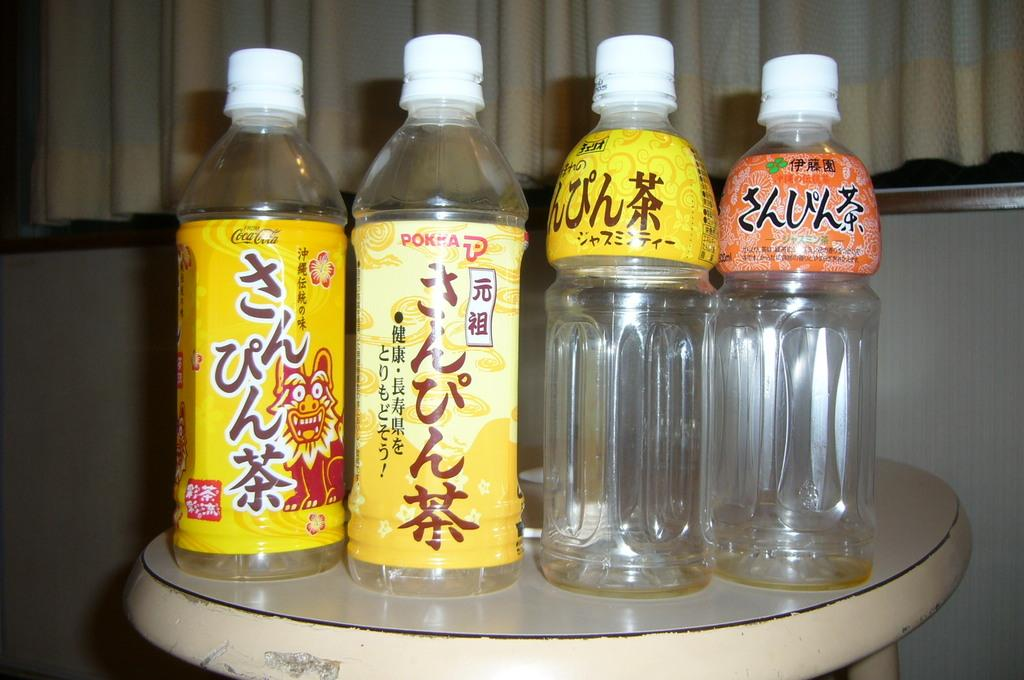<image>
Summarize the visual content of the image. Empty bottles, one of which has the brand Coca-Cola written on it. 